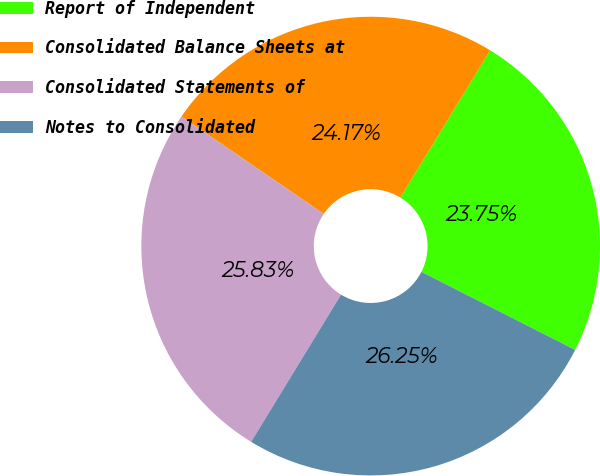Convert chart to OTSL. <chart><loc_0><loc_0><loc_500><loc_500><pie_chart><fcel>Report of Independent<fcel>Consolidated Balance Sheets at<fcel>Consolidated Statements of<fcel>Notes to Consolidated<nl><fcel>23.75%<fcel>24.17%<fcel>25.83%<fcel>26.25%<nl></chart> 